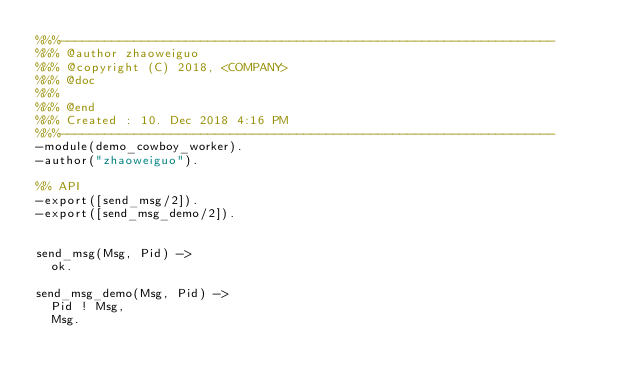<code> <loc_0><loc_0><loc_500><loc_500><_Erlang_>%%%-------------------------------------------------------------------
%%% @author zhaoweiguo
%%% @copyright (C) 2018, <COMPANY>
%%% @doc
%%%
%%% @end
%%% Created : 10. Dec 2018 4:16 PM
%%%-------------------------------------------------------------------
-module(demo_cowboy_worker).
-author("zhaoweiguo").

%% API
-export([send_msg/2]).
-export([send_msg_demo/2]).


send_msg(Msg, Pid) ->
  ok.

send_msg_demo(Msg, Pid) ->
  Pid ! Msg,
  Msg.




</code> 